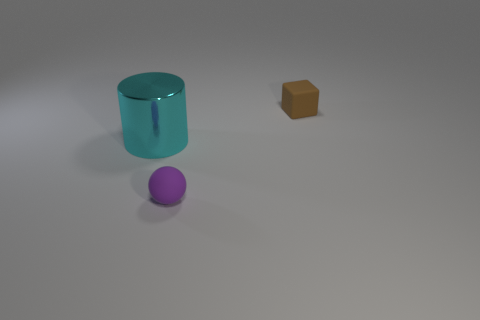Is there any other thing that is the same shape as the large cyan metallic object?
Ensure brevity in your answer.  No. The tiny rubber thing that is in front of the large cyan object has what shape?
Give a very brief answer. Sphere. What material is the object on the left side of the small object that is in front of the brown object made of?
Ensure brevity in your answer.  Metal. Are there more brown objects behind the large cyan metal cylinder than large blue metal spheres?
Provide a succinct answer. Yes. What number of other objects are there of the same color as the small rubber sphere?
Give a very brief answer. 0. There is another object that is the same size as the purple object; what is its shape?
Keep it short and to the point. Cube. There is a rubber object behind the small thing in front of the block; what number of rubber things are to the left of it?
Give a very brief answer. 1. How many metallic objects are brown cubes or tiny yellow objects?
Give a very brief answer. 0. What color is the thing that is both right of the big cyan metal cylinder and behind the small purple object?
Make the answer very short. Brown. There is a matte object behind the purple thing; is its size the same as the tiny purple thing?
Make the answer very short. Yes. 